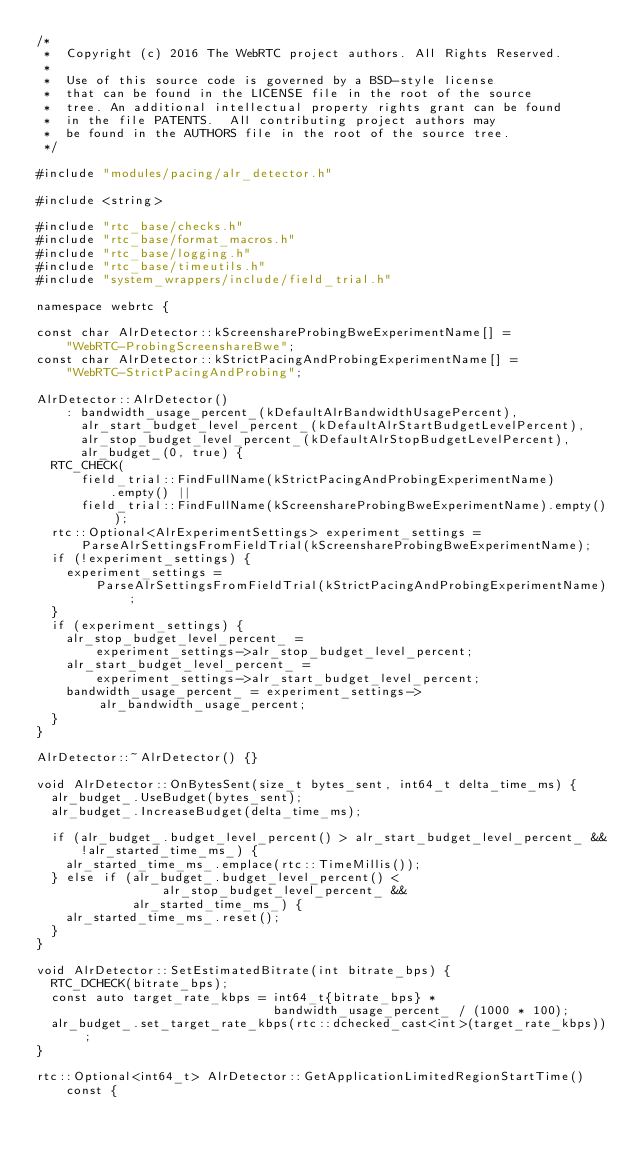Convert code to text. <code><loc_0><loc_0><loc_500><loc_500><_C++_>/*
 *  Copyright (c) 2016 The WebRTC project authors. All Rights Reserved.
 *
 *  Use of this source code is governed by a BSD-style license
 *  that can be found in the LICENSE file in the root of the source
 *  tree. An additional intellectual property rights grant can be found
 *  in the file PATENTS.  All contributing project authors may
 *  be found in the AUTHORS file in the root of the source tree.
 */

#include "modules/pacing/alr_detector.h"

#include <string>

#include "rtc_base/checks.h"
#include "rtc_base/format_macros.h"
#include "rtc_base/logging.h"
#include "rtc_base/timeutils.h"
#include "system_wrappers/include/field_trial.h"

namespace webrtc {

const char AlrDetector::kScreenshareProbingBweExperimentName[] =
    "WebRTC-ProbingScreenshareBwe";
const char AlrDetector::kStrictPacingAndProbingExperimentName[] =
    "WebRTC-StrictPacingAndProbing";

AlrDetector::AlrDetector()
    : bandwidth_usage_percent_(kDefaultAlrBandwidthUsagePercent),
      alr_start_budget_level_percent_(kDefaultAlrStartBudgetLevelPercent),
      alr_stop_budget_level_percent_(kDefaultAlrStopBudgetLevelPercent),
      alr_budget_(0, true) {
  RTC_CHECK(
      field_trial::FindFullName(kStrictPacingAndProbingExperimentName)
          .empty() ||
      field_trial::FindFullName(kScreenshareProbingBweExperimentName).empty());
  rtc::Optional<AlrExperimentSettings> experiment_settings =
      ParseAlrSettingsFromFieldTrial(kScreenshareProbingBweExperimentName);
  if (!experiment_settings) {
    experiment_settings =
        ParseAlrSettingsFromFieldTrial(kStrictPacingAndProbingExperimentName);
  }
  if (experiment_settings) {
    alr_stop_budget_level_percent_ =
        experiment_settings->alr_stop_budget_level_percent;
    alr_start_budget_level_percent_ =
        experiment_settings->alr_start_budget_level_percent;
    bandwidth_usage_percent_ = experiment_settings->alr_bandwidth_usage_percent;
  }
}

AlrDetector::~AlrDetector() {}

void AlrDetector::OnBytesSent(size_t bytes_sent, int64_t delta_time_ms) {
  alr_budget_.UseBudget(bytes_sent);
  alr_budget_.IncreaseBudget(delta_time_ms);

  if (alr_budget_.budget_level_percent() > alr_start_budget_level_percent_ &&
      !alr_started_time_ms_) {
    alr_started_time_ms_.emplace(rtc::TimeMillis());
  } else if (alr_budget_.budget_level_percent() <
                 alr_stop_budget_level_percent_ &&
             alr_started_time_ms_) {
    alr_started_time_ms_.reset();
  }
}

void AlrDetector::SetEstimatedBitrate(int bitrate_bps) {
  RTC_DCHECK(bitrate_bps);
  const auto target_rate_kbps = int64_t{bitrate_bps} *
                                bandwidth_usage_percent_ / (1000 * 100);
  alr_budget_.set_target_rate_kbps(rtc::dchecked_cast<int>(target_rate_kbps));
}

rtc::Optional<int64_t> AlrDetector::GetApplicationLimitedRegionStartTime()
    const {</code> 